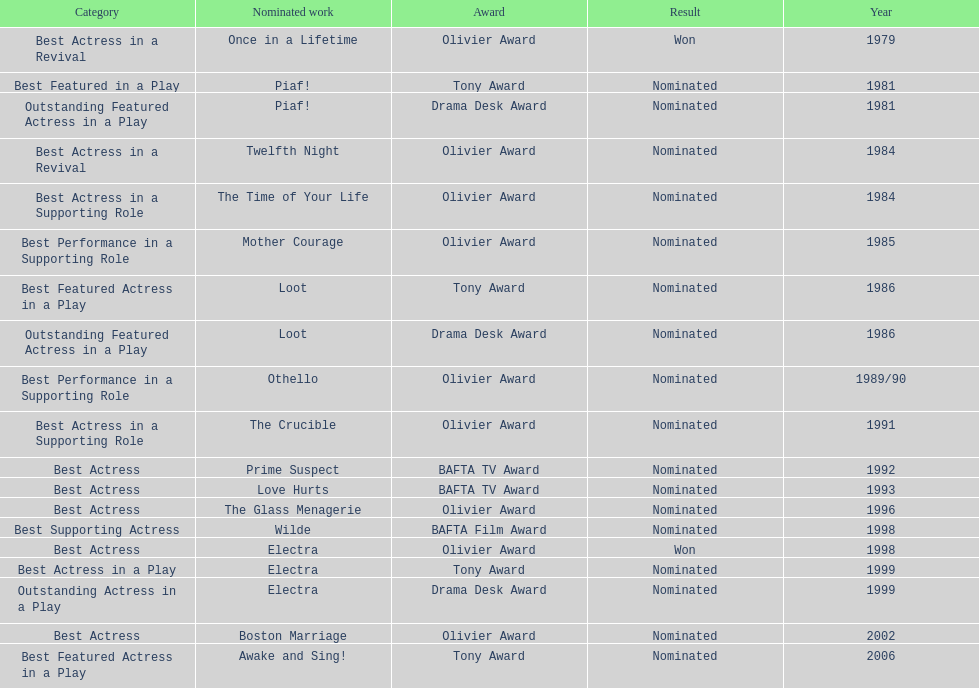What play was wanamaker nominated for best featured in a play in 1981? Piaf!. 